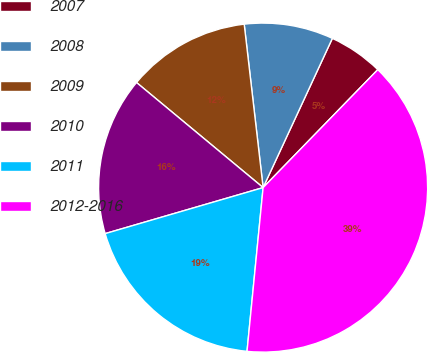Convert chart to OTSL. <chart><loc_0><loc_0><loc_500><loc_500><pie_chart><fcel>2007<fcel>2008<fcel>2009<fcel>2010<fcel>2011<fcel>2012-2016<nl><fcel>5.36%<fcel>8.75%<fcel>12.14%<fcel>15.54%<fcel>18.93%<fcel>39.29%<nl></chart> 